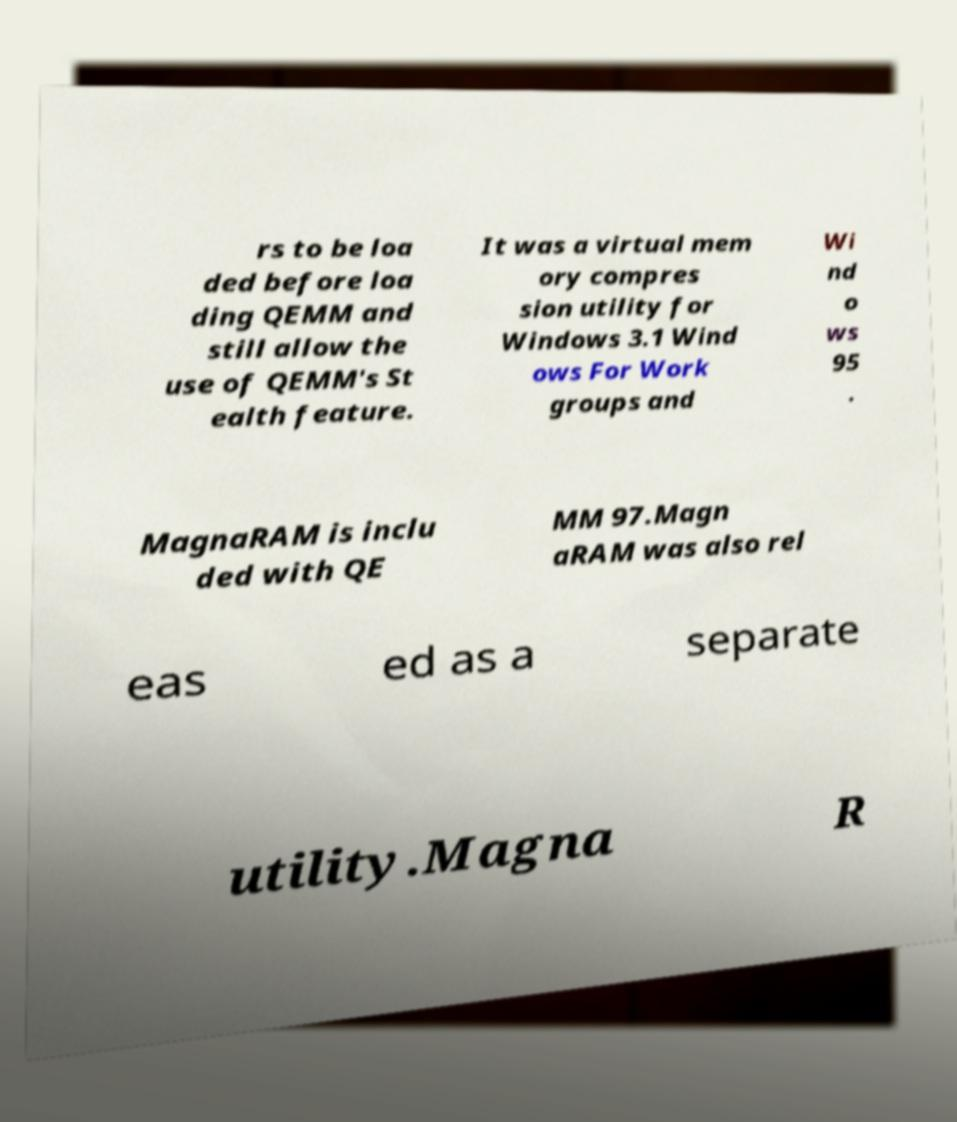Could you assist in decoding the text presented in this image and type it out clearly? rs to be loa ded before loa ding QEMM and still allow the use of QEMM's St ealth feature. It was a virtual mem ory compres sion utility for Windows 3.1 Wind ows For Work groups and Wi nd o ws 95 . MagnaRAM is inclu ded with QE MM 97.Magn aRAM was also rel eas ed as a separate utility.Magna R 